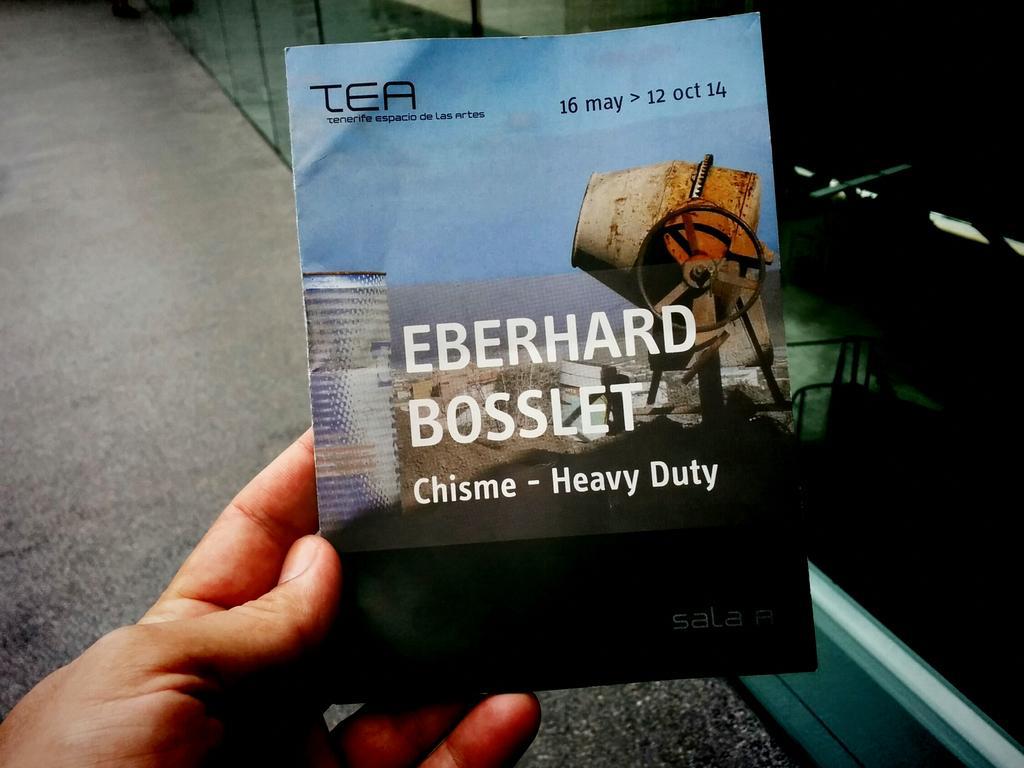Could you give a brief overview of what you see in this image? In this picture we can observe paper in the human hand which is in blue and black color. There are white and black color words on the paper. In the background we can observe road. 